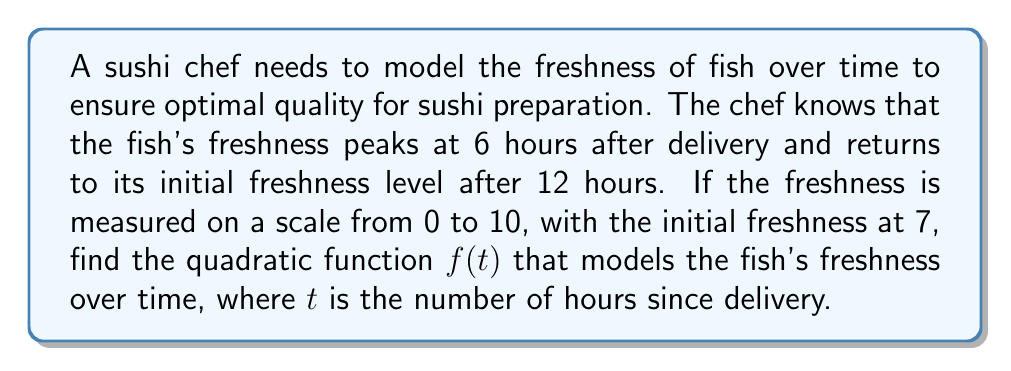Give your solution to this math problem. Let's approach this step-by-step:

1) The general form of a quadratic function is $f(t) = a(t-h)^2 + k$, where $(h,k)$ is the vertex.

2) We know the vertex is at 6 hours (peak freshness), so $h = 6$.

3) Let's define our points:
   - At $t = 0$, $f(0) = 7$ (initial freshness)
   - At $t = 6$, $f(6)$ is the peak freshness (we'll call this $k$)
   - At $t = 12$, $f(12) = 7$ (returns to initial freshness)

4) We can use the point $(0, 7)$ to find $a$:
   $7 = a(0-6)^2 + k$
   $7 = 36a + k$

5) We can use the point $(12, 7)$ to create another equation:
   $7 = a(12-6)^2 + k$
   $7 = 36a + k$

6) These equations are identical, confirming that our parabola is symmetric.

7) To find $a$, we can use the fact that the parabola drops 3 units (from $k$ to 7) over 6 units of $t$:
   $3 = 36a$
   $a = \frac{1}{12}$

8) Now we can find $k$:
   $7 = 36(\frac{1}{12}) + k$
   $7 = 3 + k$
   $k = 10$

9) Therefore, our quadratic function is:
   $f(t) = \frac{1}{12}(t-6)^2 + 10$
Answer: $f(t) = \frac{1}{12}(t-6)^2 + 10$ 